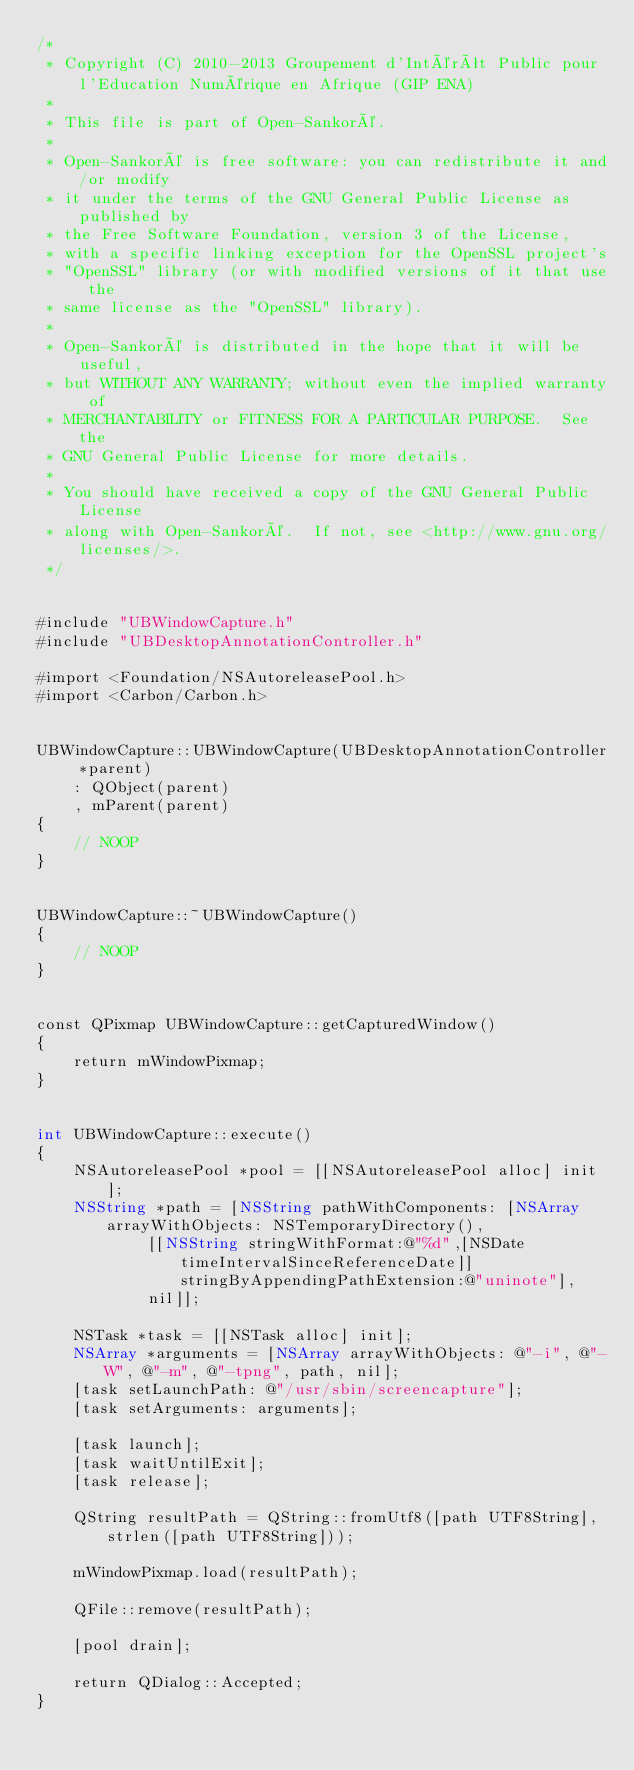<code> <loc_0><loc_0><loc_500><loc_500><_ObjectiveC_>/*
 * Copyright (C) 2010-2013 Groupement d'Intérêt Public pour l'Education Numérique en Afrique (GIP ENA)
 *
 * This file is part of Open-Sankoré.
 *
 * Open-Sankoré is free software: you can redistribute it and/or modify
 * it under the terms of the GNU General Public License as published by
 * the Free Software Foundation, version 3 of the License,
 * with a specific linking exception for the OpenSSL project's
 * "OpenSSL" library (or with modified versions of it that use the
 * same license as the "OpenSSL" library).
 *
 * Open-Sankoré is distributed in the hope that it will be useful,
 * but WITHOUT ANY WARRANTY; without even the implied warranty of
 * MERCHANTABILITY or FITNESS FOR A PARTICULAR PURPOSE.  See the
 * GNU General Public License for more details.
 *
 * You should have received a copy of the GNU General Public License
 * along with Open-Sankoré.  If not, see <http://www.gnu.org/licenses/>.
 */


#include "UBWindowCapture.h"
#include "UBDesktopAnnotationController.h"

#import <Foundation/NSAutoreleasePool.h>
#import <Carbon/Carbon.h>


UBWindowCapture::UBWindowCapture(UBDesktopAnnotationController *parent) 
	: QObject(parent)
	, mParent(parent)
{
	// NOOP
}


UBWindowCapture::~UBWindowCapture() 
{
	// NOOP
}


const QPixmap UBWindowCapture::getCapturedWindow() 
{
	return mWindowPixmap;
}


int UBWindowCapture::execute()
{
    NSAutoreleasePool *pool = [[NSAutoreleasePool alloc] init];
    NSString *path = [NSString pathWithComponents: [NSArray arrayWithObjects: NSTemporaryDirectory(), 
			[[NSString stringWithFormat:@"%d",[NSDate timeIntervalSinceReferenceDate]] stringByAppendingPathExtension:@"uninote"], 
			nil]];
	
    NSTask *task = [[NSTask alloc] init];
	NSArray *arguments = [NSArray arrayWithObjects: @"-i", @"-W", @"-m", @"-tpng", path, nil];
    [task setLaunchPath: @"/usr/sbin/screencapture"];
    [task setArguments: arguments];
	
    [task launch];
    [task waitUntilExit];
    [task release];
	
    QString resultPath = QString::fromUtf8([path UTF8String], strlen([path UTF8String]));
	
    mWindowPixmap.load(resultPath);
    
    QFile::remove(resultPath);
    
    [pool drain];
    
    return QDialog::Accepted;
}

</code> 